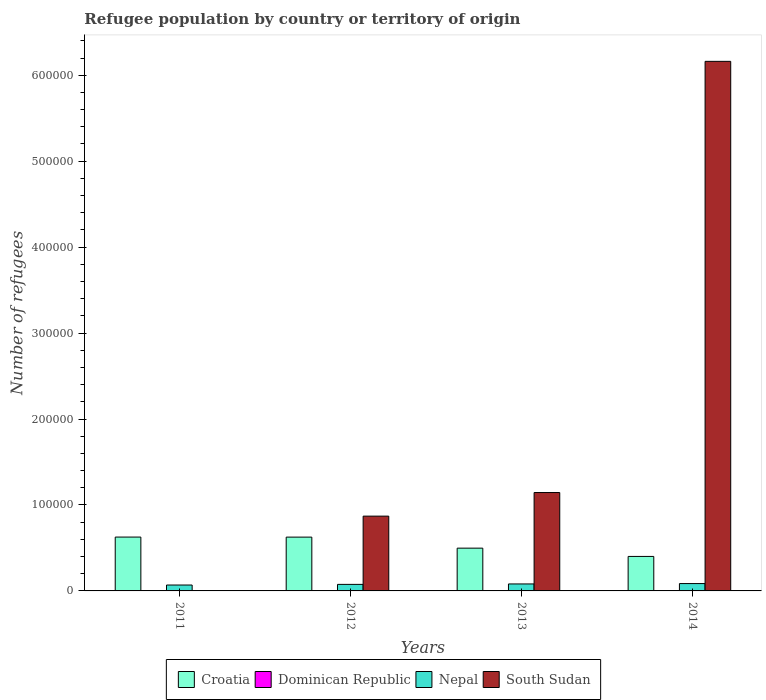How many different coloured bars are there?
Ensure brevity in your answer.  4. How many groups of bars are there?
Offer a terse response. 4. How many bars are there on the 2nd tick from the left?
Provide a short and direct response. 4. What is the number of refugees in South Sudan in 2012?
Your answer should be very brief. 8.70e+04. Across all years, what is the maximum number of refugees in Dominican Republic?
Your response must be concise. 349. Across all years, what is the minimum number of refugees in Dominican Republic?
Give a very brief answer. 250. What is the total number of refugees in Dominican Republic in the graph?
Give a very brief answer. 1194. What is the difference between the number of refugees in Dominican Republic in 2013 and that in 2014?
Give a very brief answer. -43. What is the difference between the number of refugees in South Sudan in 2012 and the number of refugees in Nepal in 2013?
Give a very brief answer. 7.89e+04. What is the average number of refugees in Croatia per year?
Offer a very short reply. 5.38e+04. In the year 2014, what is the difference between the number of refugees in Dominican Republic and number of refugees in Croatia?
Your answer should be very brief. -3.98e+04. What is the ratio of the number of refugees in Dominican Republic in 2011 to that in 2012?
Your response must be concise. 0.87. Is the difference between the number of refugees in Dominican Republic in 2012 and 2013 greater than the difference between the number of refugees in Croatia in 2012 and 2013?
Your response must be concise. No. What is the difference between the highest and the lowest number of refugees in Nepal?
Provide a succinct answer. 1707. In how many years, is the number of refugees in South Sudan greater than the average number of refugees in South Sudan taken over all years?
Provide a succinct answer. 1. Is the sum of the number of refugees in Nepal in 2011 and 2014 greater than the maximum number of refugees in South Sudan across all years?
Make the answer very short. No. What does the 2nd bar from the left in 2011 represents?
Provide a succinct answer. Dominican Republic. What does the 1st bar from the right in 2014 represents?
Your answer should be very brief. South Sudan. Is it the case that in every year, the sum of the number of refugees in Croatia and number of refugees in Dominican Republic is greater than the number of refugees in South Sudan?
Make the answer very short. No. How many bars are there?
Provide a succinct answer. 16. How many years are there in the graph?
Ensure brevity in your answer.  4. What is the difference between two consecutive major ticks on the Y-axis?
Your response must be concise. 1.00e+05. Does the graph contain any zero values?
Ensure brevity in your answer.  No. Does the graph contain grids?
Your response must be concise. No. Where does the legend appear in the graph?
Keep it short and to the point. Bottom center. How many legend labels are there?
Offer a very short reply. 4. How are the legend labels stacked?
Keep it short and to the point. Horizontal. What is the title of the graph?
Provide a short and direct response. Refugee population by country or territory of origin. What is the label or title of the Y-axis?
Ensure brevity in your answer.  Number of refugees. What is the Number of refugees of Croatia in 2011?
Provide a succinct answer. 6.26e+04. What is the Number of refugees in Dominican Republic in 2011?
Give a very brief answer. 250. What is the Number of refugees of Nepal in 2011?
Your answer should be compact. 6854. What is the Number of refugees of Croatia in 2012?
Give a very brief answer. 6.26e+04. What is the Number of refugees of Dominican Republic in 2012?
Your answer should be very brief. 289. What is the Number of refugees in Nepal in 2012?
Offer a terse response. 7612. What is the Number of refugees in South Sudan in 2012?
Offer a terse response. 8.70e+04. What is the Number of refugees of Croatia in 2013?
Provide a succinct answer. 4.98e+04. What is the Number of refugees in Dominican Republic in 2013?
Provide a short and direct response. 306. What is the Number of refugees of Nepal in 2013?
Give a very brief answer. 8112. What is the Number of refugees in South Sudan in 2013?
Offer a very short reply. 1.14e+05. What is the Number of refugees of Croatia in 2014?
Keep it short and to the point. 4.01e+04. What is the Number of refugees in Dominican Republic in 2014?
Provide a succinct answer. 349. What is the Number of refugees in Nepal in 2014?
Keep it short and to the point. 8561. What is the Number of refugees of South Sudan in 2014?
Ensure brevity in your answer.  6.16e+05. Across all years, what is the maximum Number of refugees in Croatia?
Offer a terse response. 6.26e+04. Across all years, what is the maximum Number of refugees in Dominican Republic?
Your answer should be very brief. 349. Across all years, what is the maximum Number of refugees in Nepal?
Provide a succinct answer. 8561. Across all years, what is the maximum Number of refugees in South Sudan?
Make the answer very short. 6.16e+05. Across all years, what is the minimum Number of refugees of Croatia?
Provide a succinct answer. 4.01e+04. Across all years, what is the minimum Number of refugees of Dominican Republic?
Ensure brevity in your answer.  250. Across all years, what is the minimum Number of refugees in Nepal?
Your answer should be compact. 6854. Across all years, what is the minimum Number of refugees of South Sudan?
Your answer should be compact. 1. What is the total Number of refugees of Croatia in the graph?
Provide a short and direct response. 2.15e+05. What is the total Number of refugees of Dominican Republic in the graph?
Ensure brevity in your answer.  1194. What is the total Number of refugees of Nepal in the graph?
Ensure brevity in your answer.  3.11e+04. What is the total Number of refugees in South Sudan in the graph?
Make the answer very short. 8.18e+05. What is the difference between the Number of refugees of Croatia in 2011 and that in 2012?
Provide a short and direct response. 43. What is the difference between the Number of refugees in Dominican Republic in 2011 and that in 2012?
Offer a very short reply. -39. What is the difference between the Number of refugees of Nepal in 2011 and that in 2012?
Make the answer very short. -758. What is the difference between the Number of refugees in South Sudan in 2011 and that in 2012?
Your response must be concise. -8.70e+04. What is the difference between the Number of refugees in Croatia in 2011 and that in 2013?
Make the answer very short. 1.29e+04. What is the difference between the Number of refugees of Dominican Republic in 2011 and that in 2013?
Provide a short and direct response. -56. What is the difference between the Number of refugees in Nepal in 2011 and that in 2013?
Make the answer very short. -1258. What is the difference between the Number of refugees in South Sudan in 2011 and that in 2013?
Keep it short and to the point. -1.14e+05. What is the difference between the Number of refugees in Croatia in 2011 and that in 2014?
Keep it short and to the point. 2.25e+04. What is the difference between the Number of refugees in Dominican Republic in 2011 and that in 2014?
Offer a terse response. -99. What is the difference between the Number of refugees of Nepal in 2011 and that in 2014?
Offer a very short reply. -1707. What is the difference between the Number of refugees in South Sudan in 2011 and that in 2014?
Provide a succinct answer. -6.16e+05. What is the difference between the Number of refugees of Croatia in 2012 and that in 2013?
Your answer should be compact. 1.28e+04. What is the difference between the Number of refugees in Dominican Republic in 2012 and that in 2013?
Offer a terse response. -17. What is the difference between the Number of refugees in Nepal in 2012 and that in 2013?
Ensure brevity in your answer.  -500. What is the difference between the Number of refugees of South Sudan in 2012 and that in 2013?
Offer a very short reply. -2.75e+04. What is the difference between the Number of refugees of Croatia in 2012 and that in 2014?
Provide a succinct answer. 2.25e+04. What is the difference between the Number of refugees of Dominican Republic in 2012 and that in 2014?
Offer a very short reply. -60. What is the difference between the Number of refugees of Nepal in 2012 and that in 2014?
Give a very brief answer. -949. What is the difference between the Number of refugees of South Sudan in 2012 and that in 2014?
Ensure brevity in your answer.  -5.29e+05. What is the difference between the Number of refugees in Croatia in 2013 and that in 2014?
Offer a very short reply. 9634. What is the difference between the Number of refugees in Dominican Republic in 2013 and that in 2014?
Your response must be concise. -43. What is the difference between the Number of refugees of Nepal in 2013 and that in 2014?
Offer a very short reply. -449. What is the difference between the Number of refugees of South Sudan in 2013 and that in 2014?
Your answer should be very brief. -5.02e+05. What is the difference between the Number of refugees in Croatia in 2011 and the Number of refugees in Dominican Republic in 2012?
Ensure brevity in your answer.  6.24e+04. What is the difference between the Number of refugees in Croatia in 2011 and the Number of refugees in Nepal in 2012?
Ensure brevity in your answer.  5.50e+04. What is the difference between the Number of refugees in Croatia in 2011 and the Number of refugees in South Sudan in 2012?
Give a very brief answer. -2.44e+04. What is the difference between the Number of refugees of Dominican Republic in 2011 and the Number of refugees of Nepal in 2012?
Give a very brief answer. -7362. What is the difference between the Number of refugees in Dominican Republic in 2011 and the Number of refugees in South Sudan in 2012?
Your response must be concise. -8.68e+04. What is the difference between the Number of refugees in Nepal in 2011 and the Number of refugees in South Sudan in 2012?
Ensure brevity in your answer.  -8.02e+04. What is the difference between the Number of refugees in Croatia in 2011 and the Number of refugees in Dominican Republic in 2013?
Keep it short and to the point. 6.23e+04. What is the difference between the Number of refugees in Croatia in 2011 and the Number of refugees in Nepal in 2013?
Make the answer very short. 5.45e+04. What is the difference between the Number of refugees in Croatia in 2011 and the Number of refugees in South Sudan in 2013?
Give a very brief answer. -5.18e+04. What is the difference between the Number of refugees of Dominican Republic in 2011 and the Number of refugees of Nepal in 2013?
Provide a succinct answer. -7862. What is the difference between the Number of refugees in Dominican Republic in 2011 and the Number of refugees in South Sudan in 2013?
Your answer should be very brief. -1.14e+05. What is the difference between the Number of refugees of Nepal in 2011 and the Number of refugees of South Sudan in 2013?
Provide a short and direct response. -1.08e+05. What is the difference between the Number of refugees in Croatia in 2011 and the Number of refugees in Dominican Republic in 2014?
Make the answer very short. 6.23e+04. What is the difference between the Number of refugees in Croatia in 2011 and the Number of refugees in Nepal in 2014?
Offer a terse response. 5.41e+04. What is the difference between the Number of refugees in Croatia in 2011 and the Number of refugees in South Sudan in 2014?
Offer a very short reply. -5.53e+05. What is the difference between the Number of refugees in Dominican Republic in 2011 and the Number of refugees in Nepal in 2014?
Provide a short and direct response. -8311. What is the difference between the Number of refugees of Dominican Republic in 2011 and the Number of refugees of South Sudan in 2014?
Your response must be concise. -6.16e+05. What is the difference between the Number of refugees of Nepal in 2011 and the Number of refugees of South Sudan in 2014?
Ensure brevity in your answer.  -6.09e+05. What is the difference between the Number of refugees of Croatia in 2012 and the Number of refugees of Dominican Republic in 2013?
Make the answer very short. 6.23e+04. What is the difference between the Number of refugees in Croatia in 2012 and the Number of refugees in Nepal in 2013?
Provide a succinct answer. 5.45e+04. What is the difference between the Number of refugees in Croatia in 2012 and the Number of refugees in South Sudan in 2013?
Offer a terse response. -5.19e+04. What is the difference between the Number of refugees in Dominican Republic in 2012 and the Number of refugees in Nepal in 2013?
Your answer should be compact. -7823. What is the difference between the Number of refugees in Dominican Republic in 2012 and the Number of refugees in South Sudan in 2013?
Your response must be concise. -1.14e+05. What is the difference between the Number of refugees in Nepal in 2012 and the Number of refugees in South Sudan in 2013?
Ensure brevity in your answer.  -1.07e+05. What is the difference between the Number of refugees in Croatia in 2012 and the Number of refugees in Dominican Republic in 2014?
Give a very brief answer. 6.23e+04. What is the difference between the Number of refugees of Croatia in 2012 and the Number of refugees of Nepal in 2014?
Your answer should be very brief. 5.40e+04. What is the difference between the Number of refugees of Croatia in 2012 and the Number of refugees of South Sudan in 2014?
Provide a succinct answer. -5.54e+05. What is the difference between the Number of refugees in Dominican Republic in 2012 and the Number of refugees in Nepal in 2014?
Give a very brief answer. -8272. What is the difference between the Number of refugees of Dominican Republic in 2012 and the Number of refugees of South Sudan in 2014?
Your answer should be compact. -6.16e+05. What is the difference between the Number of refugees in Nepal in 2012 and the Number of refugees in South Sudan in 2014?
Your answer should be compact. -6.09e+05. What is the difference between the Number of refugees in Croatia in 2013 and the Number of refugees in Dominican Republic in 2014?
Your answer should be very brief. 4.94e+04. What is the difference between the Number of refugees of Croatia in 2013 and the Number of refugees of Nepal in 2014?
Give a very brief answer. 4.12e+04. What is the difference between the Number of refugees of Croatia in 2013 and the Number of refugees of South Sudan in 2014?
Provide a succinct answer. -5.66e+05. What is the difference between the Number of refugees of Dominican Republic in 2013 and the Number of refugees of Nepal in 2014?
Offer a terse response. -8255. What is the difference between the Number of refugees in Dominican Republic in 2013 and the Number of refugees in South Sudan in 2014?
Offer a very short reply. -6.16e+05. What is the difference between the Number of refugees in Nepal in 2013 and the Number of refugees in South Sudan in 2014?
Your answer should be compact. -6.08e+05. What is the average Number of refugees of Croatia per year?
Your response must be concise. 5.38e+04. What is the average Number of refugees of Dominican Republic per year?
Offer a very short reply. 298.5. What is the average Number of refugees of Nepal per year?
Offer a terse response. 7784.75. What is the average Number of refugees in South Sudan per year?
Ensure brevity in your answer.  2.04e+05. In the year 2011, what is the difference between the Number of refugees in Croatia and Number of refugees in Dominican Republic?
Provide a short and direct response. 6.24e+04. In the year 2011, what is the difference between the Number of refugees of Croatia and Number of refugees of Nepal?
Make the answer very short. 5.58e+04. In the year 2011, what is the difference between the Number of refugees in Croatia and Number of refugees in South Sudan?
Provide a short and direct response. 6.26e+04. In the year 2011, what is the difference between the Number of refugees of Dominican Republic and Number of refugees of Nepal?
Provide a succinct answer. -6604. In the year 2011, what is the difference between the Number of refugees in Dominican Republic and Number of refugees in South Sudan?
Offer a terse response. 249. In the year 2011, what is the difference between the Number of refugees in Nepal and Number of refugees in South Sudan?
Offer a terse response. 6853. In the year 2012, what is the difference between the Number of refugees of Croatia and Number of refugees of Dominican Republic?
Your answer should be compact. 6.23e+04. In the year 2012, what is the difference between the Number of refugees of Croatia and Number of refugees of Nepal?
Your response must be concise. 5.50e+04. In the year 2012, what is the difference between the Number of refugees of Croatia and Number of refugees of South Sudan?
Keep it short and to the point. -2.44e+04. In the year 2012, what is the difference between the Number of refugees of Dominican Republic and Number of refugees of Nepal?
Your answer should be compact. -7323. In the year 2012, what is the difference between the Number of refugees of Dominican Republic and Number of refugees of South Sudan?
Offer a terse response. -8.67e+04. In the year 2012, what is the difference between the Number of refugees of Nepal and Number of refugees of South Sudan?
Make the answer very short. -7.94e+04. In the year 2013, what is the difference between the Number of refugees of Croatia and Number of refugees of Dominican Republic?
Your answer should be very brief. 4.95e+04. In the year 2013, what is the difference between the Number of refugees of Croatia and Number of refugees of Nepal?
Provide a succinct answer. 4.16e+04. In the year 2013, what is the difference between the Number of refugees in Croatia and Number of refugees in South Sudan?
Provide a succinct answer. -6.47e+04. In the year 2013, what is the difference between the Number of refugees of Dominican Republic and Number of refugees of Nepal?
Offer a terse response. -7806. In the year 2013, what is the difference between the Number of refugees of Dominican Republic and Number of refugees of South Sudan?
Ensure brevity in your answer.  -1.14e+05. In the year 2013, what is the difference between the Number of refugees in Nepal and Number of refugees in South Sudan?
Make the answer very short. -1.06e+05. In the year 2014, what is the difference between the Number of refugees of Croatia and Number of refugees of Dominican Republic?
Your answer should be very brief. 3.98e+04. In the year 2014, what is the difference between the Number of refugees in Croatia and Number of refugees in Nepal?
Your answer should be compact. 3.16e+04. In the year 2014, what is the difference between the Number of refugees of Croatia and Number of refugees of South Sudan?
Make the answer very short. -5.76e+05. In the year 2014, what is the difference between the Number of refugees in Dominican Republic and Number of refugees in Nepal?
Provide a short and direct response. -8212. In the year 2014, what is the difference between the Number of refugees in Dominican Republic and Number of refugees in South Sudan?
Give a very brief answer. -6.16e+05. In the year 2014, what is the difference between the Number of refugees of Nepal and Number of refugees of South Sudan?
Keep it short and to the point. -6.08e+05. What is the ratio of the Number of refugees of Dominican Republic in 2011 to that in 2012?
Make the answer very short. 0.87. What is the ratio of the Number of refugees in Nepal in 2011 to that in 2012?
Provide a short and direct response. 0.9. What is the ratio of the Number of refugees of Croatia in 2011 to that in 2013?
Give a very brief answer. 1.26. What is the ratio of the Number of refugees in Dominican Republic in 2011 to that in 2013?
Offer a terse response. 0.82. What is the ratio of the Number of refugees of Nepal in 2011 to that in 2013?
Offer a very short reply. 0.84. What is the ratio of the Number of refugees in South Sudan in 2011 to that in 2013?
Your answer should be compact. 0. What is the ratio of the Number of refugees in Croatia in 2011 to that in 2014?
Offer a very short reply. 1.56. What is the ratio of the Number of refugees in Dominican Republic in 2011 to that in 2014?
Offer a terse response. 0.72. What is the ratio of the Number of refugees of Nepal in 2011 to that in 2014?
Provide a succinct answer. 0.8. What is the ratio of the Number of refugees in South Sudan in 2011 to that in 2014?
Ensure brevity in your answer.  0. What is the ratio of the Number of refugees of Croatia in 2012 to that in 2013?
Provide a short and direct response. 1.26. What is the ratio of the Number of refugees of Nepal in 2012 to that in 2013?
Ensure brevity in your answer.  0.94. What is the ratio of the Number of refugees in South Sudan in 2012 to that in 2013?
Your answer should be compact. 0.76. What is the ratio of the Number of refugees in Croatia in 2012 to that in 2014?
Give a very brief answer. 1.56. What is the ratio of the Number of refugees of Dominican Republic in 2012 to that in 2014?
Keep it short and to the point. 0.83. What is the ratio of the Number of refugees of Nepal in 2012 to that in 2014?
Offer a very short reply. 0.89. What is the ratio of the Number of refugees in South Sudan in 2012 to that in 2014?
Make the answer very short. 0.14. What is the ratio of the Number of refugees of Croatia in 2013 to that in 2014?
Provide a succinct answer. 1.24. What is the ratio of the Number of refugees of Dominican Republic in 2013 to that in 2014?
Provide a succinct answer. 0.88. What is the ratio of the Number of refugees of Nepal in 2013 to that in 2014?
Your answer should be very brief. 0.95. What is the ratio of the Number of refugees of South Sudan in 2013 to that in 2014?
Provide a short and direct response. 0.19. What is the difference between the highest and the second highest Number of refugees of Croatia?
Your response must be concise. 43. What is the difference between the highest and the second highest Number of refugees of Dominican Republic?
Make the answer very short. 43. What is the difference between the highest and the second highest Number of refugees in Nepal?
Offer a very short reply. 449. What is the difference between the highest and the second highest Number of refugees of South Sudan?
Provide a short and direct response. 5.02e+05. What is the difference between the highest and the lowest Number of refugees in Croatia?
Provide a short and direct response. 2.25e+04. What is the difference between the highest and the lowest Number of refugees in Dominican Republic?
Ensure brevity in your answer.  99. What is the difference between the highest and the lowest Number of refugees in Nepal?
Provide a succinct answer. 1707. What is the difference between the highest and the lowest Number of refugees in South Sudan?
Your answer should be compact. 6.16e+05. 